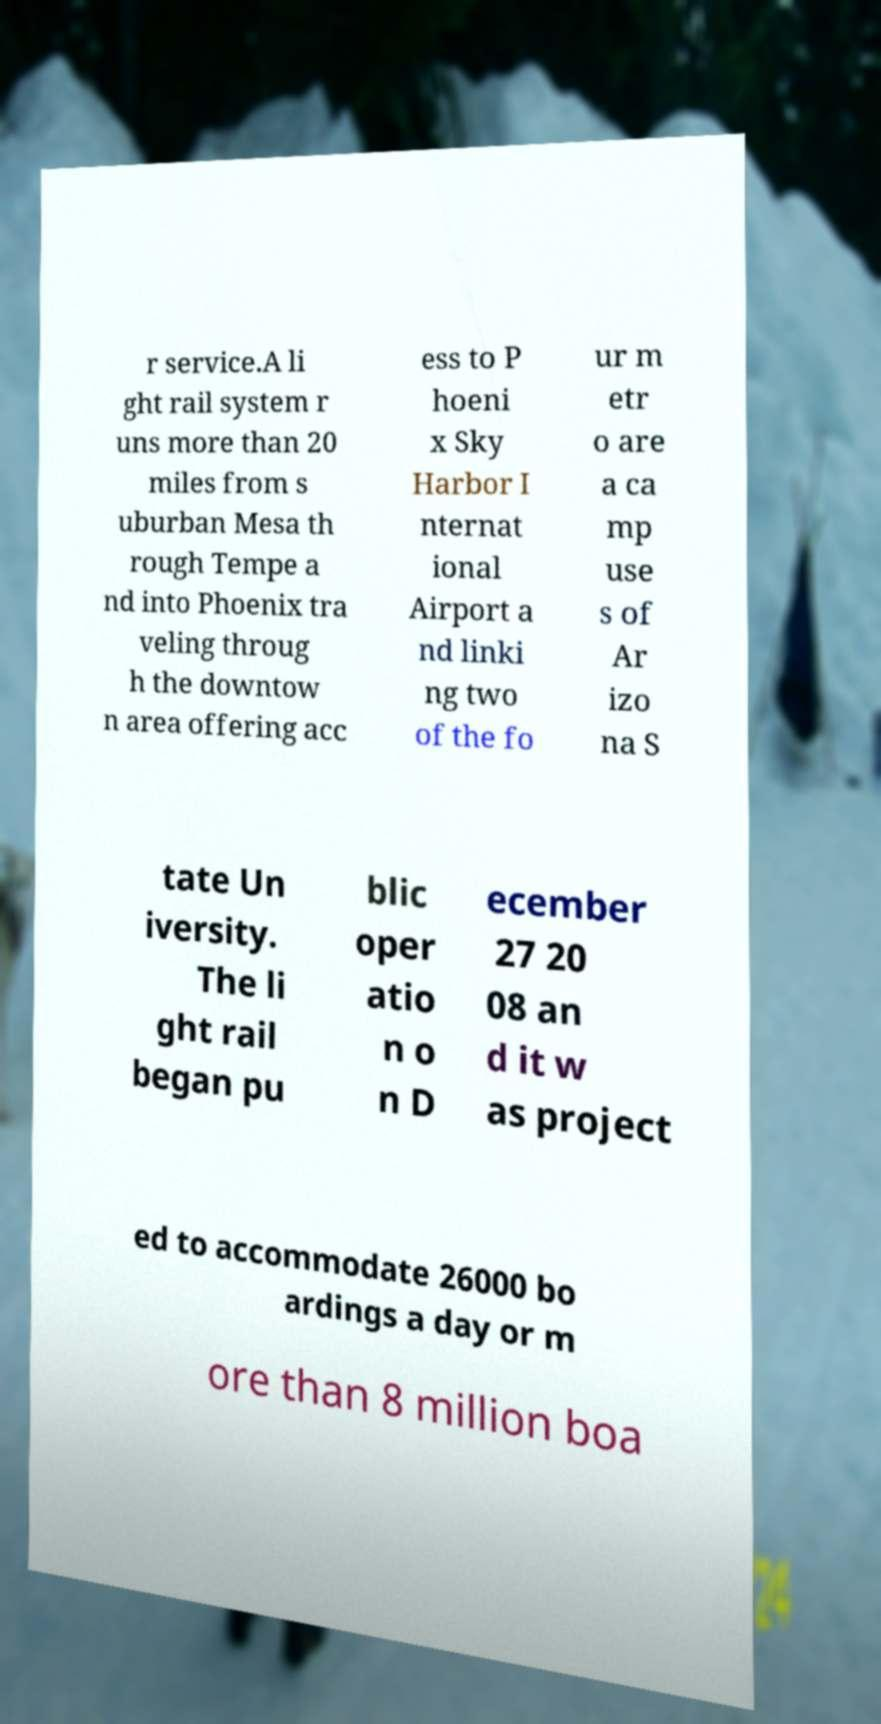For documentation purposes, I need the text within this image transcribed. Could you provide that? r service.A li ght rail system r uns more than 20 miles from s uburban Mesa th rough Tempe a nd into Phoenix tra veling throug h the downtow n area offering acc ess to P hoeni x Sky Harbor I nternat ional Airport a nd linki ng two of the fo ur m etr o are a ca mp use s of Ar izo na S tate Un iversity. The li ght rail began pu blic oper atio n o n D ecember 27 20 08 an d it w as project ed to accommodate 26000 bo ardings a day or m ore than 8 million boa 